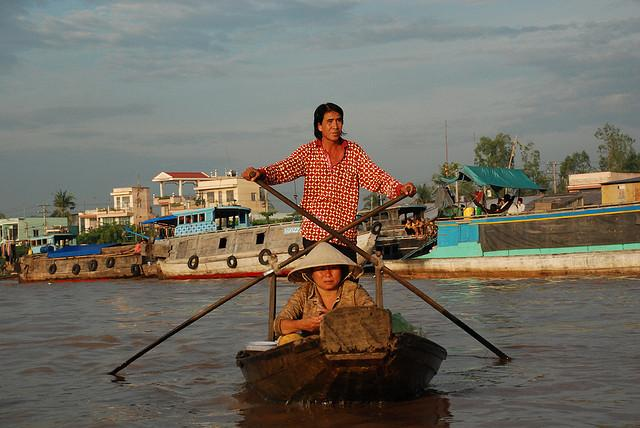What shape are the oars forming? cross 